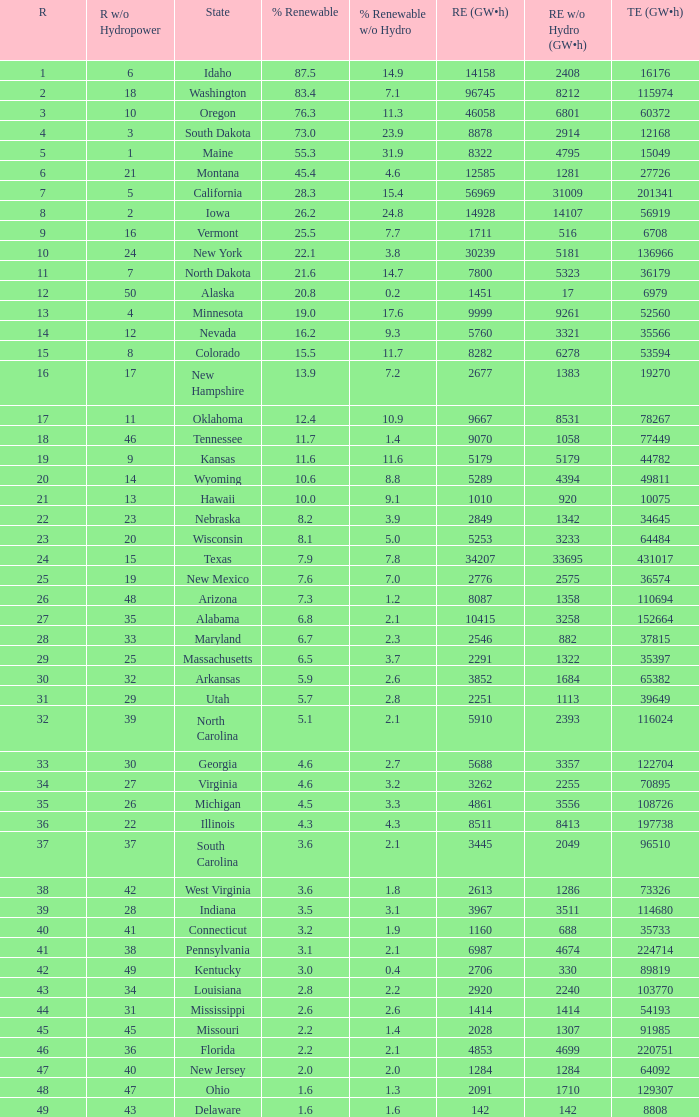What is the percentage of renewable electricity without hydrogen power in the state of South Dakota? 23.9. 